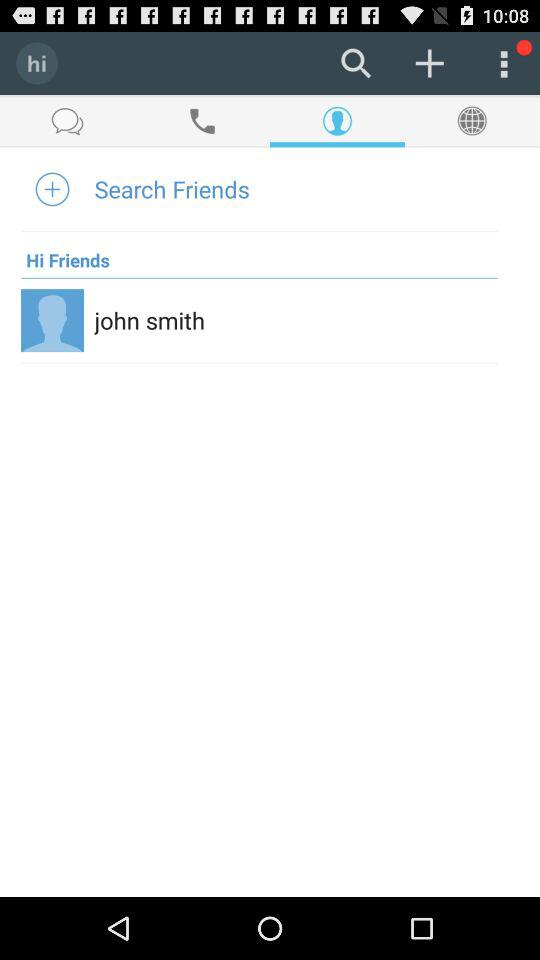Which tab is selected? The selected tab is "Contacts". 